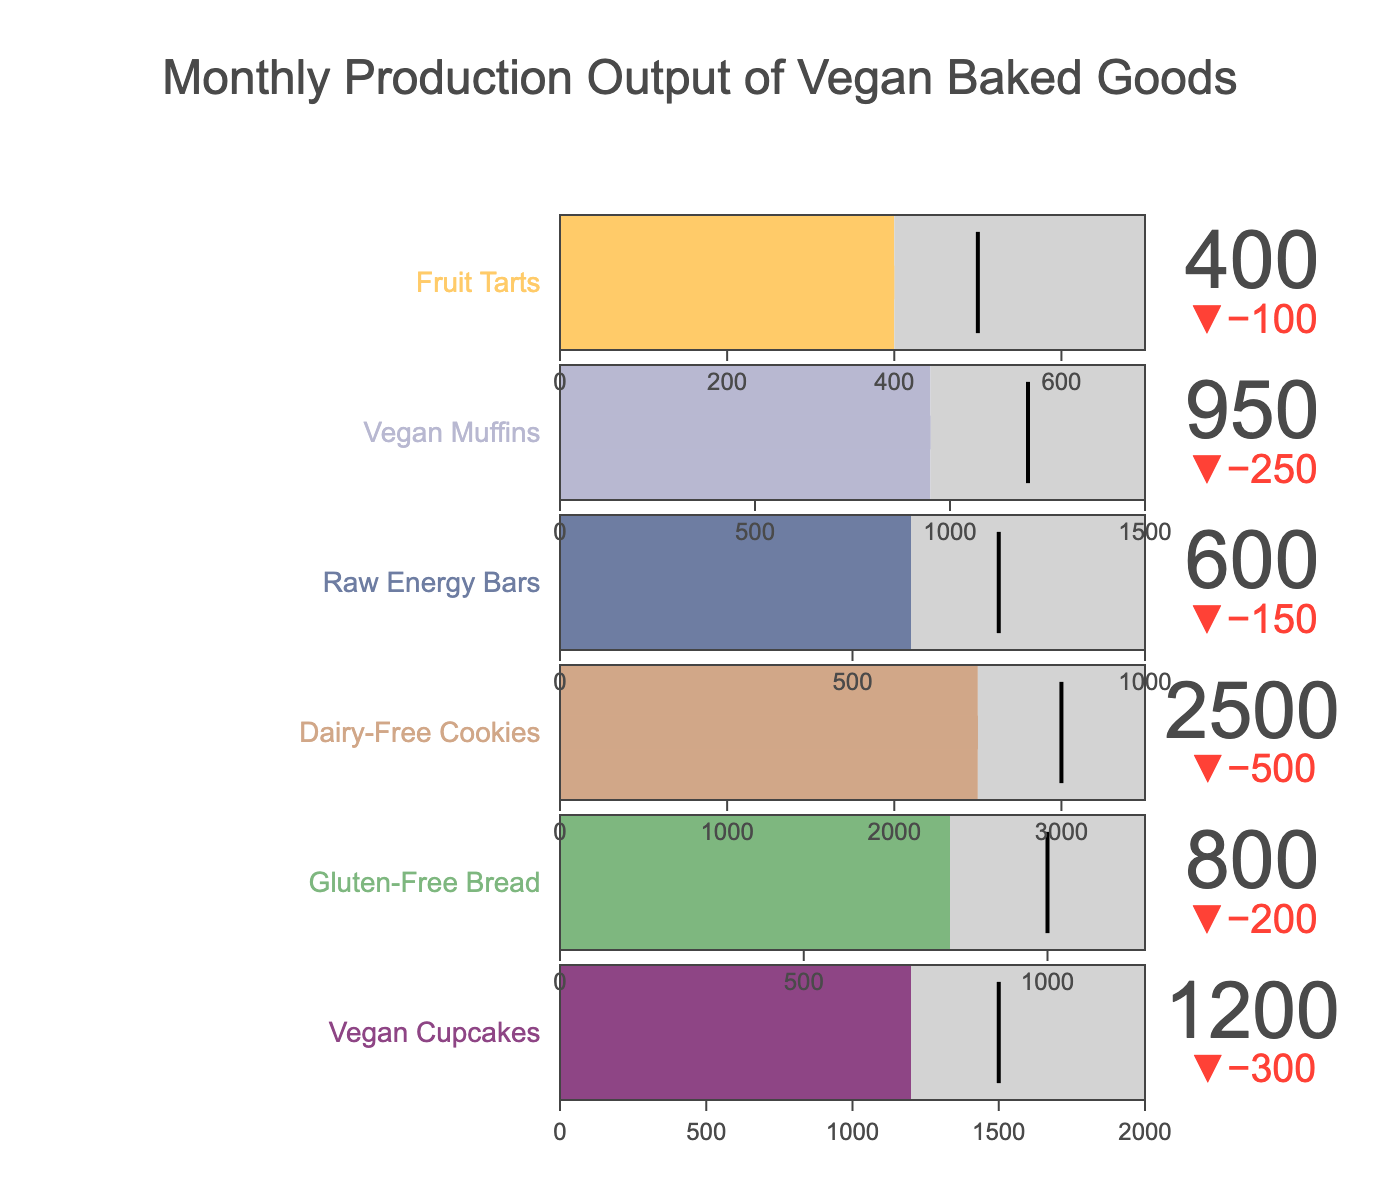What's the title of the figure? The title is typically displayed at the top of the graph and provides context about what the graph represents.
Answer: Monthly Production Output of Vegan Baked Goods How many types of vegan baked goods are shown in the figure? Count each unique product in the figure; there are 6 different types listed.
Answer: 6 Which product has the highest actual production output? Compare the actual production values for all products. The actual output is highest for Dairy-Free Cookies at 2500.
Answer: Dairy-Free Cookies What is the target production for Raw Energy Bars? Locate the segment for Raw Energy Bars and read the target production value. The target is 750.
Answer: 750 For which product is the actual production closest to the target value? Compare the actual and target values for each product to find the smallest difference. For Vegan Muffins, the actual (950) and target (1200) values have a difference of 250, which is the smallest.
Answer: Vegan Muffins What is the color used to represent Vegan Cupcakes? Identify the color associated with Vegan Cupcakes in the figure; it is a shade of purple.
Answer: Purple Which product has the largest capacity value? Compare the capacity values for all products. Dairy-Free Cookies has the largest capacity at 3500.
Answer: Dairy-Free Cookies How much more is the capacity than the actual production for Fruit Tarts? Subtract the actual production from the capacity for Fruit Tarts: 700 (Capacity) - 400 (Actual) = 300.
Answer: 300 What is the difference between the actual and target production for Gluten-Free Bread? Subtract the actual production from the target production for Gluten-Free Bread: 1000 (Target) - 800 (Actual) = 200.
Answer: 200 Which product has the smallest actual production output? Compare the actual production outputs for all products. Fruit Tarts have the smallest actual output at 400.
Answer: Fruit Tarts 